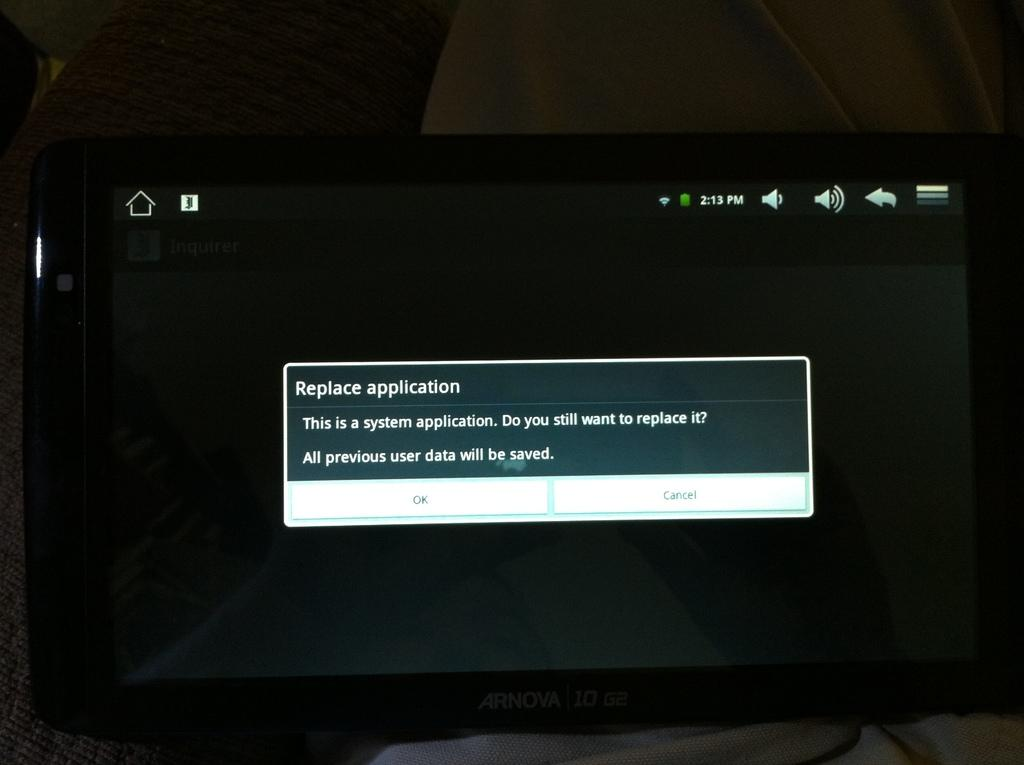Provide a one-sentence caption for the provided image. An Ornova computer monitor with the message "Replace application". 